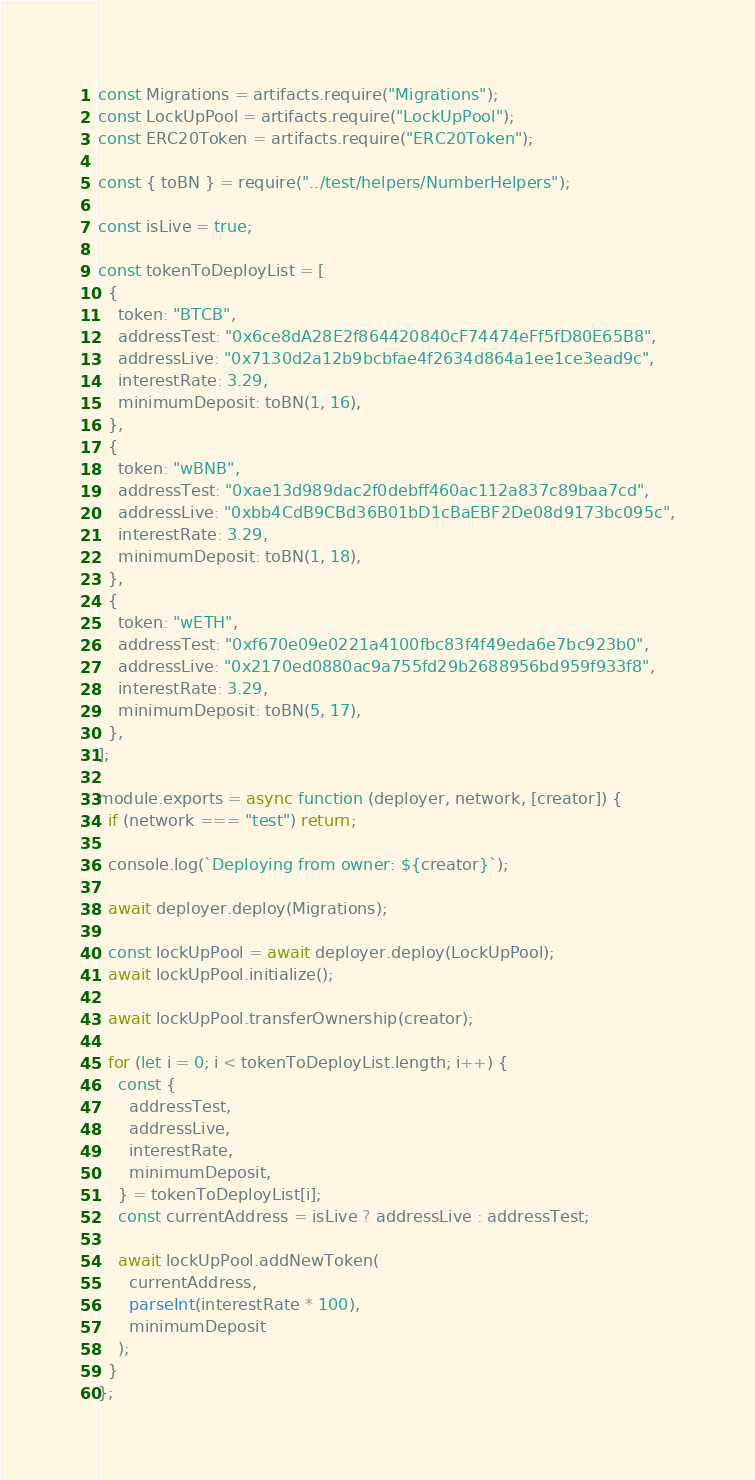Convert code to text. <code><loc_0><loc_0><loc_500><loc_500><_JavaScript_>const Migrations = artifacts.require("Migrations");
const LockUpPool = artifacts.require("LockUpPool");
const ERC20Token = artifacts.require("ERC20Token");

const { toBN } = require("../test/helpers/NumberHelpers");

const isLive = true;

const tokenToDeployList = [
  {
    token: "BTCB",
    addressTest: "0x6ce8dA28E2f864420840cF74474eFf5fD80E65B8",
    addressLive: "0x7130d2a12b9bcbfae4f2634d864a1ee1ce3ead9c",
    interestRate: 3.29,
    minimumDeposit: toBN(1, 16),
  },
  {
    token: "wBNB",
    addressTest: "0xae13d989dac2f0debff460ac112a837c89baa7cd",
    addressLive: "0xbb4CdB9CBd36B01bD1cBaEBF2De08d9173bc095c",
    interestRate: 3.29,
    minimumDeposit: toBN(1, 18),
  },
  {
    token: "wETH",
    addressTest: "0xf670e09e0221a4100fbc83f4f49eda6e7bc923b0",
    addressLive: "0x2170ed0880ac9a755fd29b2688956bd959f933f8",
    interestRate: 3.29,
    minimumDeposit: toBN(5, 17),
  },
];

module.exports = async function (deployer, network, [creator]) {
  if (network === "test") return;

  console.log(`Deploying from owner: ${creator}`);

  await deployer.deploy(Migrations);

  const lockUpPool = await deployer.deploy(LockUpPool);
  await lockUpPool.initialize();

  await lockUpPool.transferOwnership(creator);

  for (let i = 0; i < tokenToDeployList.length; i++) {
    const {
      addressTest,
      addressLive,
      interestRate,
      minimumDeposit,
    } = tokenToDeployList[i];
    const currentAddress = isLive ? addressLive : addressTest;

    await lockUpPool.addNewToken(
      currentAddress,
      parseInt(interestRate * 100),
      minimumDeposit
    );
  }
};
</code> 